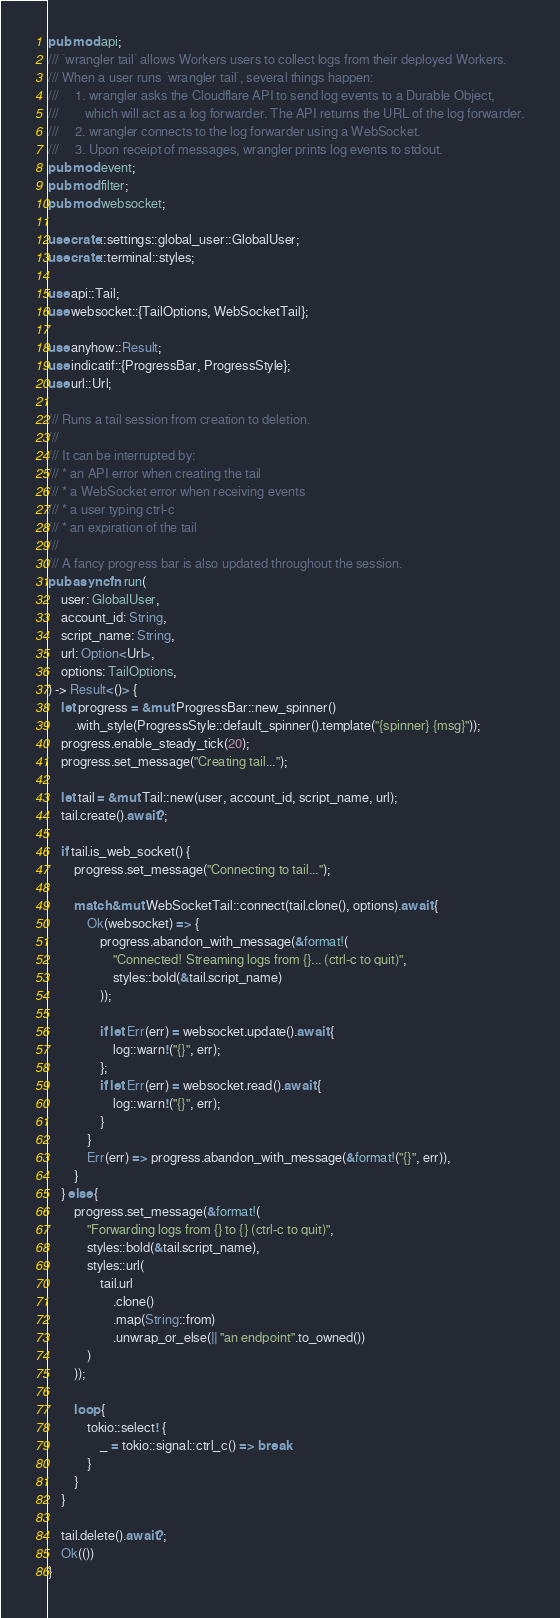Convert code to text. <code><loc_0><loc_0><loc_500><loc_500><_Rust_>pub mod api;
/// `wrangler tail` allows Workers users to collect logs from their deployed Workers.
/// When a user runs `wrangler tail`, several things happen:
///     1. wrangler asks the Cloudflare API to send log events to a Durable Object,
///        which will act as a log forwarder. The API returns the URL of the log forwarder.
///     2. wrangler connects to the log forwarder using a WebSocket.
///     3. Upon receipt of messages, wrangler prints log events to stdout.
pub mod event;
pub mod filter;
pub mod websocket;

use crate::settings::global_user::GlobalUser;
use crate::terminal::styles;

use api::Tail;
use websocket::{TailOptions, WebSocketTail};

use anyhow::Result;
use indicatif::{ProgressBar, ProgressStyle};
use url::Url;

/// Runs a tail session from creation to deletion.
///
/// It can be interrupted by:
/// * an API error when creating the tail
/// * a WebSocket error when receiving events
/// * a user typing ctrl-c
/// * an expiration of the tail
///
/// A fancy progress bar is also updated throughout the session.
pub async fn run(
    user: GlobalUser,
    account_id: String,
    script_name: String,
    url: Option<Url>,
    options: TailOptions,
) -> Result<()> {
    let progress = &mut ProgressBar::new_spinner()
        .with_style(ProgressStyle::default_spinner().template("{spinner} {msg}"));
    progress.enable_steady_tick(20);
    progress.set_message("Creating tail...");

    let tail = &mut Tail::new(user, account_id, script_name, url);
    tail.create().await?;

    if tail.is_web_socket() {
        progress.set_message("Connecting to tail...");

        match &mut WebSocketTail::connect(tail.clone(), options).await {
            Ok(websocket) => {
                progress.abandon_with_message(&format!(
                    "Connected! Streaming logs from {}... (ctrl-c to quit)",
                    styles::bold(&tail.script_name)
                ));

                if let Err(err) = websocket.update().await {
                    log::warn!("{}", err);
                };
                if let Err(err) = websocket.read().await {
                    log::warn!("{}", err);
                }
            }
            Err(err) => progress.abandon_with_message(&format!("{}", err)),
        }
    } else {
        progress.set_message(&format!(
            "Forwarding logs from {} to {} (ctrl-c to quit)",
            styles::bold(&tail.script_name),
            styles::url(
                tail.url
                    .clone()
                    .map(String::from)
                    .unwrap_or_else(|| "an endpoint".to_owned())
            )
        ));

        loop {
            tokio::select! {
                _ = tokio::signal::ctrl_c() => break
            }
        }
    }

    tail.delete().await?;
    Ok(())
}
</code> 